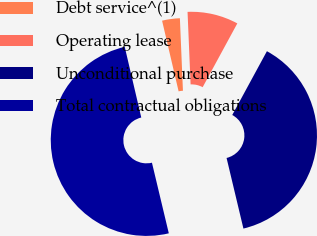Convert chart. <chart><loc_0><loc_0><loc_500><loc_500><pie_chart><fcel>Debt service^(1)<fcel>Operating lease<fcel>Unconditional purchase<fcel>Total contractual obligations<nl><fcel>2.99%<fcel>8.59%<fcel>38.35%<fcel>50.07%<nl></chart> 